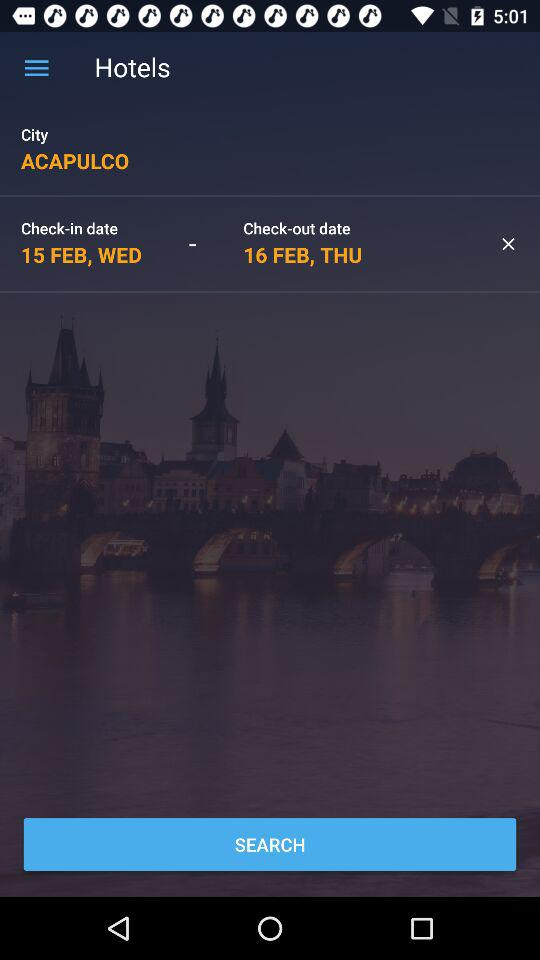What is the check in date? The check in date is February 15, Wednesday. 